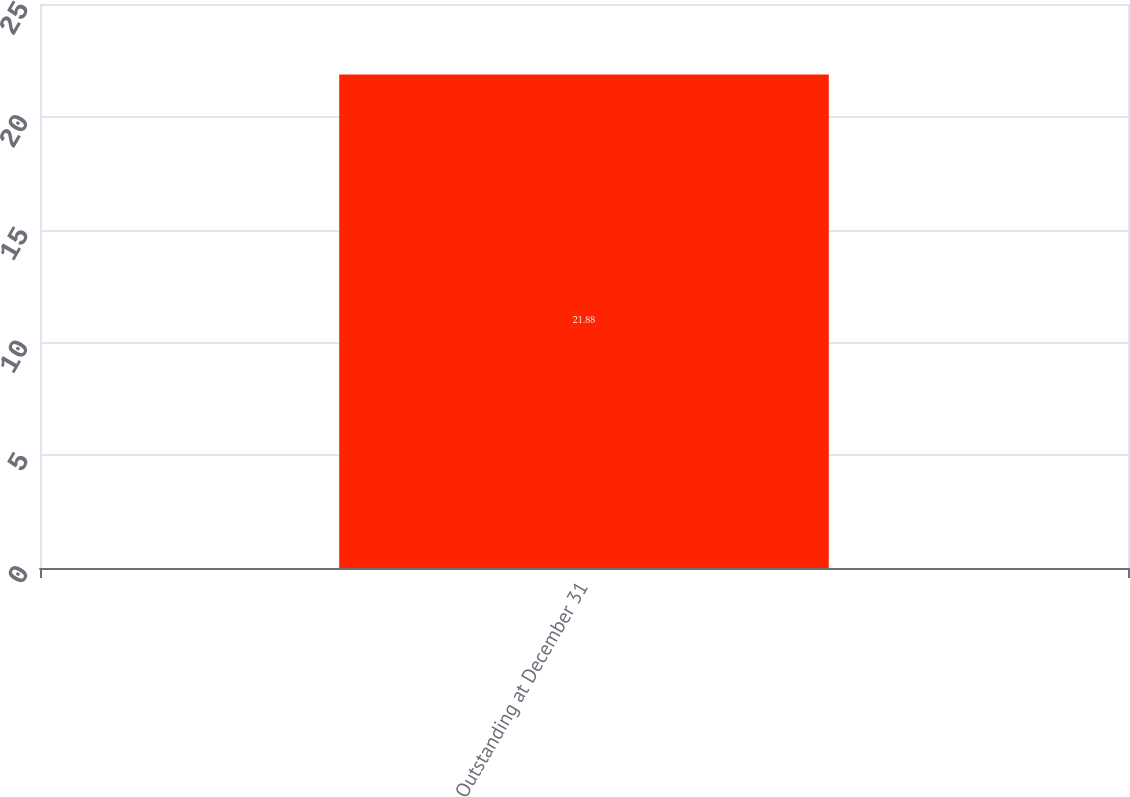<chart> <loc_0><loc_0><loc_500><loc_500><bar_chart><fcel>Outstanding at December 31<nl><fcel>21.88<nl></chart> 